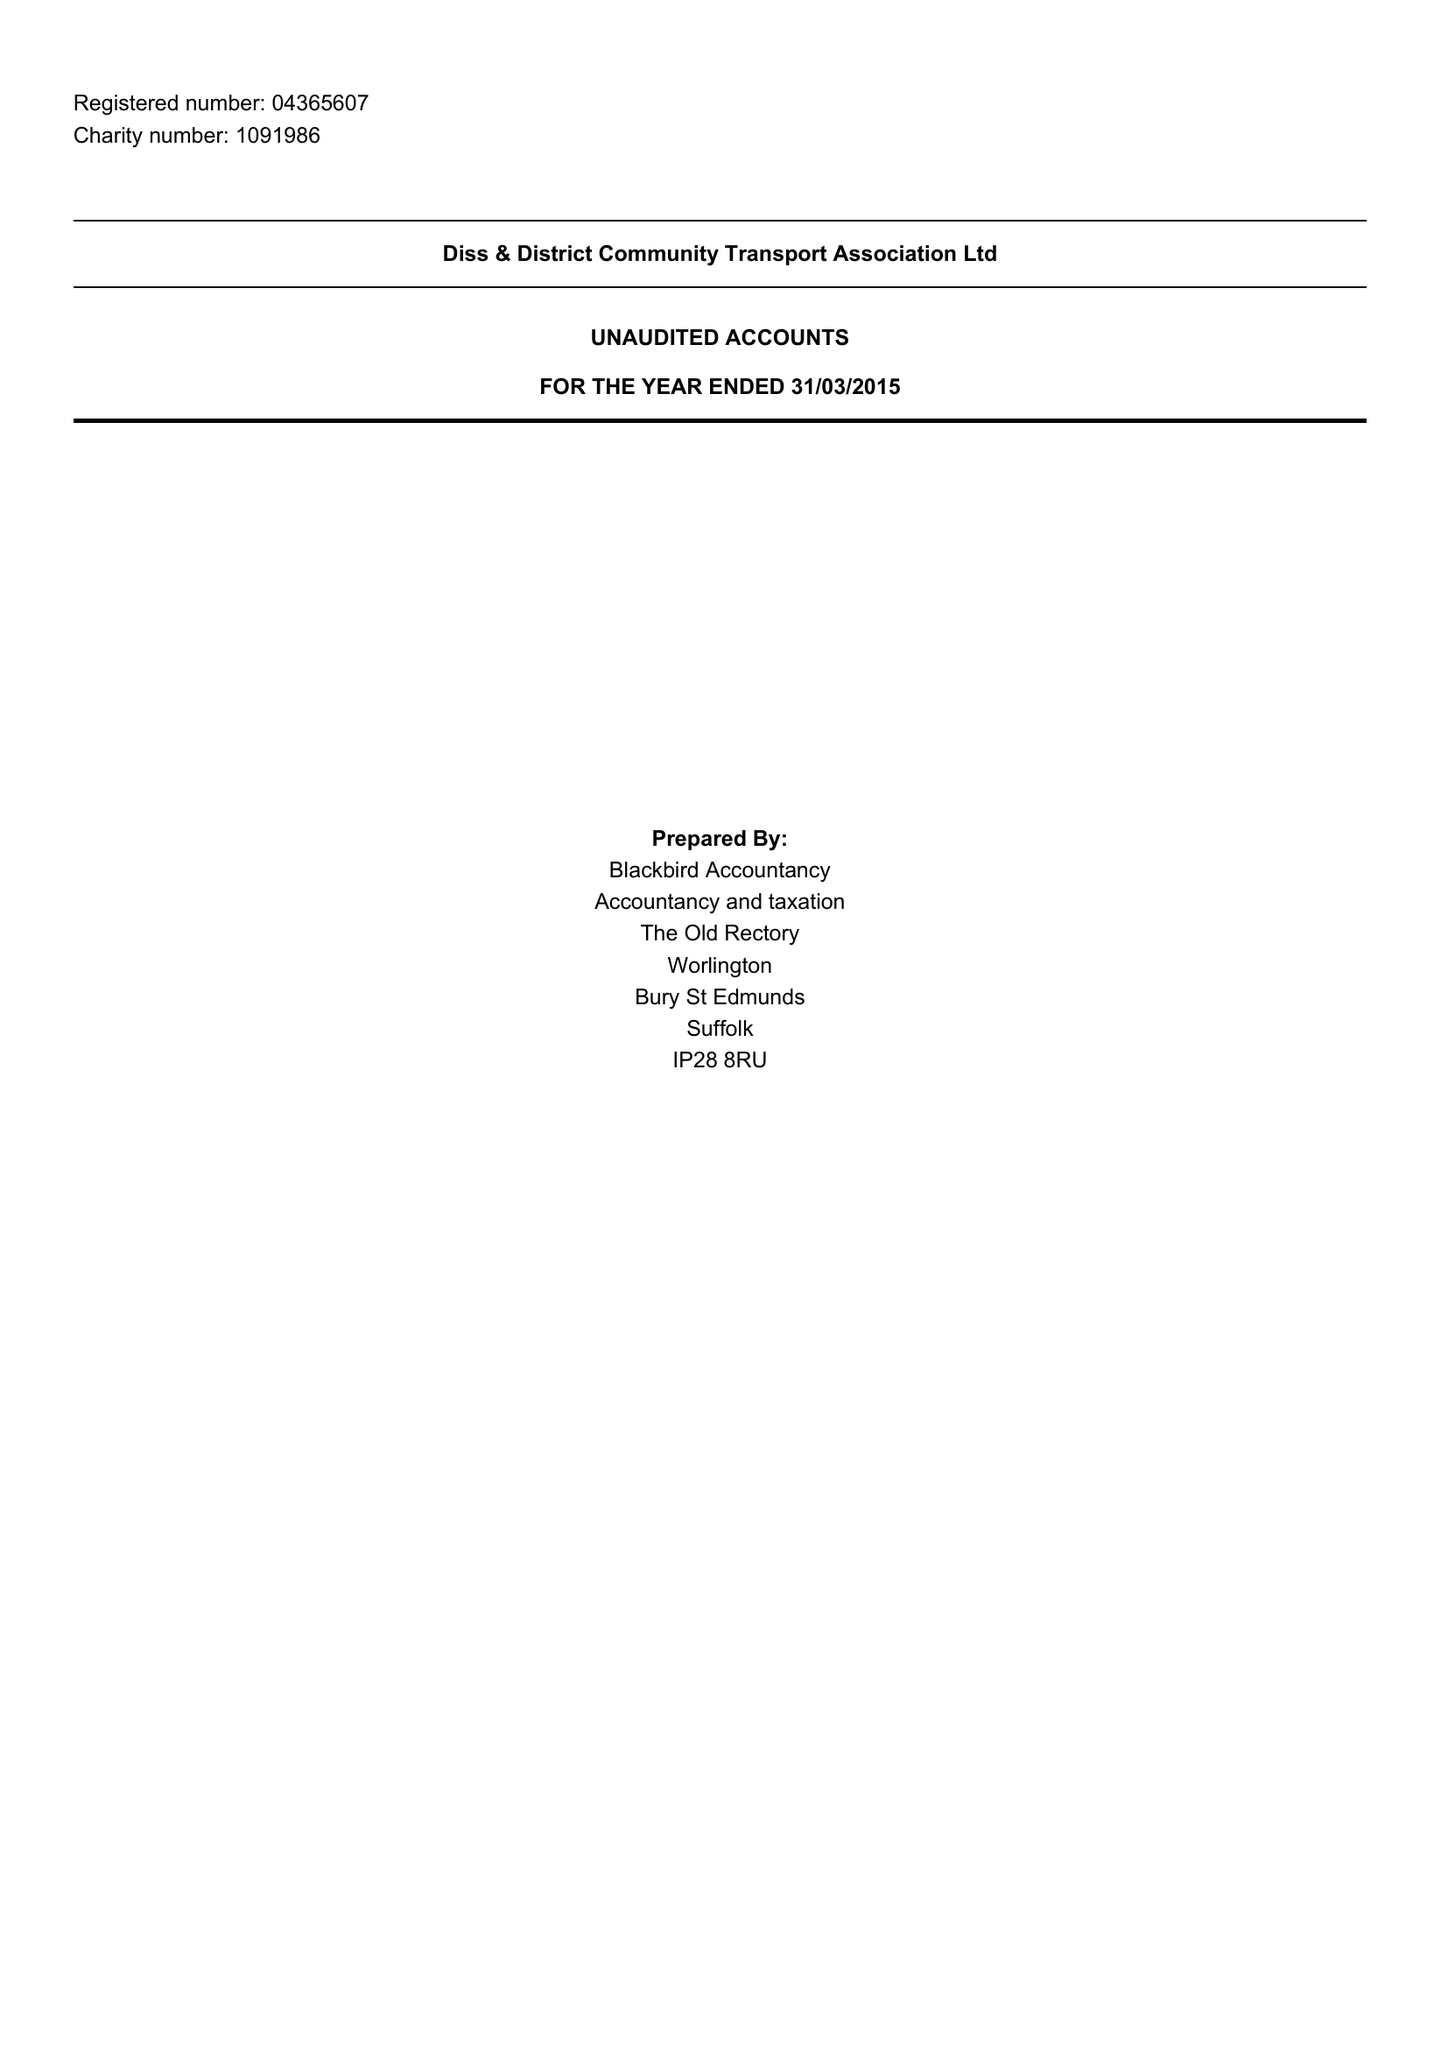What is the value for the address__post_town?
Answer the question using a single word or phrase. EYE 